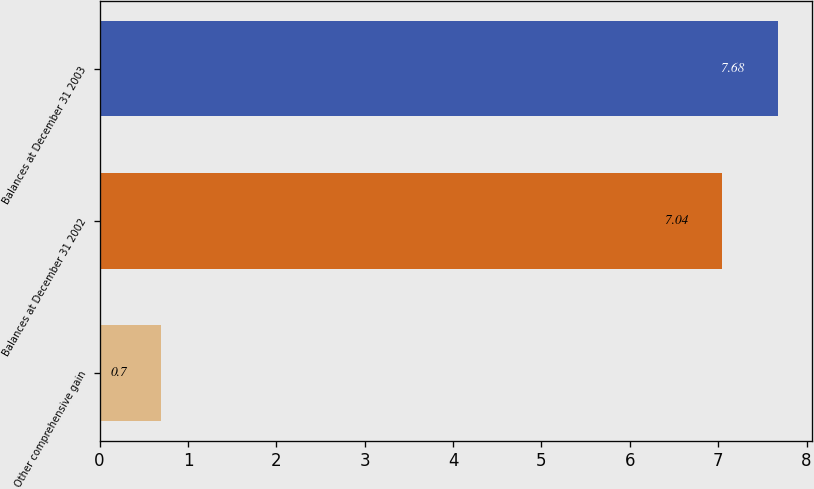<chart> <loc_0><loc_0><loc_500><loc_500><bar_chart><fcel>Other comprehensive gain<fcel>Balances at December 31 2002<fcel>Balances at December 31 2003<nl><fcel>0.7<fcel>7.04<fcel>7.68<nl></chart> 